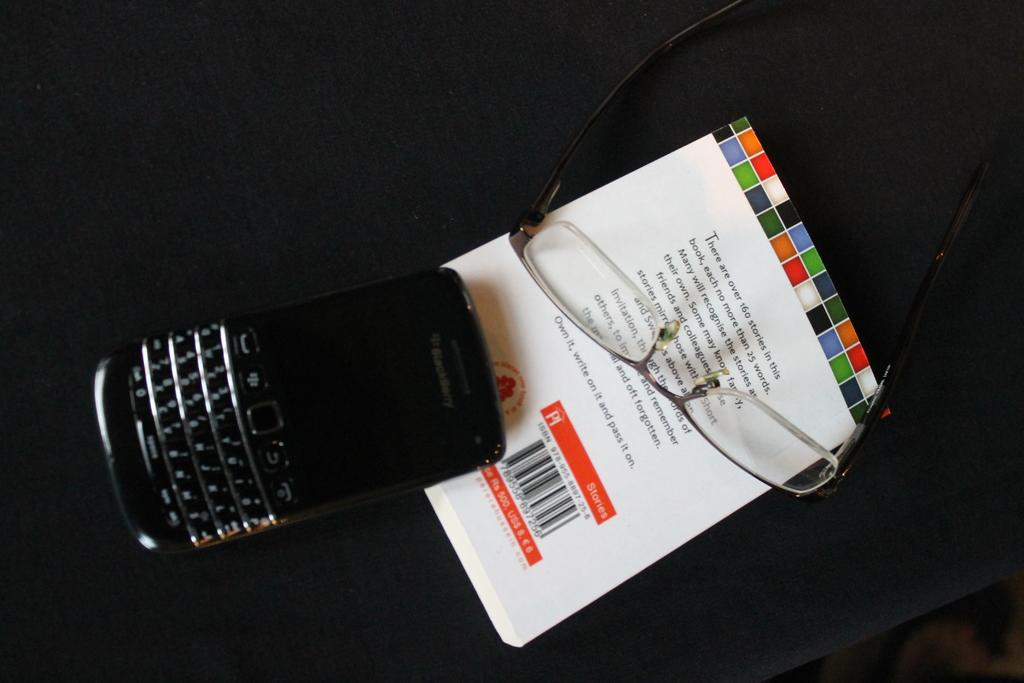<image>
Relay a brief, clear account of the picture shown. A pair of glasses rests on a book that claims to have over 160 stories in it. 